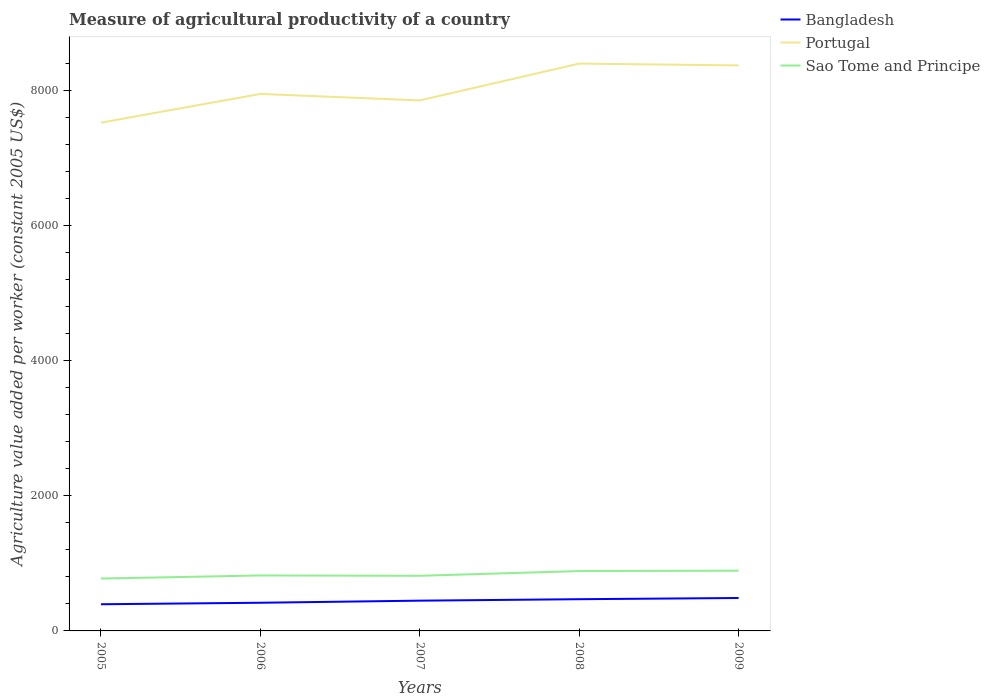Does the line corresponding to Sao Tome and Principe intersect with the line corresponding to Bangladesh?
Ensure brevity in your answer.  No. Across all years, what is the maximum measure of agricultural productivity in Portugal?
Provide a short and direct response. 7523.26. In which year was the measure of agricultural productivity in Portugal maximum?
Give a very brief answer. 2005. What is the total measure of agricultural productivity in Sao Tome and Principe in the graph?
Provide a succinct answer. -65. What is the difference between the highest and the second highest measure of agricultural productivity in Sao Tome and Principe?
Your answer should be very brief. 116.65. What is the difference between the highest and the lowest measure of agricultural productivity in Bangladesh?
Give a very brief answer. 3. How many lines are there?
Your response must be concise. 3. What is the difference between two consecutive major ticks on the Y-axis?
Offer a terse response. 2000. Are the values on the major ticks of Y-axis written in scientific E-notation?
Give a very brief answer. No. Does the graph contain any zero values?
Offer a terse response. No. Where does the legend appear in the graph?
Your response must be concise. Top right. How many legend labels are there?
Your response must be concise. 3. How are the legend labels stacked?
Offer a terse response. Vertical. What is the title of the graph?
Your response must be concise. Measure of agricultural productivity of a country. Does "Lower middle income" appear as one of the legend labels in the graph?
Offer a very short reply. No. What is the label or title of the Y-axis?
Provide a short and direct response. Agriculture value added per worker (constant 2005 US$). What is the Agriculture value added per worker (constant 2005 US$) in Bangladesh in 2005?
Offer a terse response. 394.83. What is the Agriculture value added per worker (constant 2005 US$) of Portugal in 2005?
Keep it short and to the point. 7523.26. What is the Agriculture value added per worker (constant 2005 US$) in Sao Tome and Principe in 2005?
Offer a very short reply. 775.12. What is the Agriculture value added per worker (constant 2005 US$) in Bangladesh in 2006?
Your answer should be compact. 416.92. What is the Agriculture value added per worker (constant 2005 US$) of Portugal in 2006?
Ensure brevity in your answer.  7947.86. What is the Agriculture value added per worker (constant 2005 US$) of Sao Tome and Principe in 2006?
Your answer should be compact. 820.96. What is the Agriculture value added per worker (constant 2005 US$) in Bangladesh in 2007?
Keep it short and to the point. 447.87. What is the Agriculture value added per worker (constant 2005 US$) of Portugal in 2007?
Provide a short and direct response. 7851.93. What is the Agriculture value added per worker (constant 2005 US$) in Sao Tome and Principe in 2007?
Give a very brief answer. 815.85. What is the Agriculture value added per worker (constant 2005 US$) in Bangladesh in 2008?
Offer a very short reply. 469.38. What is the Agriculture value added per worker (constant 2005 US$) of Portugal in 2008?
Ensure brevity in your answer.  8396.68. What is the Agriculture value added per worker (constant 2005 US$) in Sao Tome and Principe in 2008?
Offer a very short reply. 885.96. What is the Agriculture value added per worker (constant 2005 US$) in Bangladesh in 2009?
Offer a terse response. 487.34. What is the Agriculture value added per worker (constant 2005 US$) in Portugal in 2009?
Provide a succinct answer. 8370.22. What is the Agriculture value added per worker (constant 2005 US$) in Sao Tome and Principe in 2009?
Give a very brief answer. 891.77. Across all years, what is the maximum Agriculture value added per worker (constant 2005 US$) of Bangladesh?
Provide a short and direct response. 487.34. Across all years, what is the maximum Agriculture value added per worker (constant 2005 US$) of Portugal?
Offer a terse response. 8396.68. Across all years, what is the maximum Agriculture value added per worker (constant 2005 US$) of Sao Tome and Principe?
Provide a succinct answer. 891.77. Across all years, what is the minimum Agriculture value added per worker (constant 2005 US$) of Bangladesh?
Give a very brief answer. 394.83. Across all years, what is the minimum Agriculture value added per worker (constant 2005 US$) of Portugal?
Keep it short and to the point. 7523.26. Across all years, what is the minimum Agriculture value added per worker (constant 2005 US$) of Sao Tome and Principe?
Provide a succinct answer. 775.12. What is the total Agriculture value added per worker (constant 2005 US$) in Bangladesh in the graph?
Your answer should be very brief. 2216.33. What is the total Agriculture value added per worker (constant 2005 US$) in Portugal in the graph?
Ensure brevity in your answer.  4.01e+04. What is the total Agriculture value added per worker (constant 2005 US$) in Sao Tome and Principe in the graph?
Offer a terse response. 4189.66. What is the difference between the Agriculture value added per worker (constant 2005 US$) in Bangladesh in 2005 and that in 2006?
Give a very brief answer. -22.09. What is the difference between the Agriculture value added per worker (constant 2005 US$) of Portugal in 2005 and that in 2006?
Your response must be concise. -424.6. What is the difference between the Agriculture value added per worker (constant 2005 US$) in Sao Tome and Principe in 2005 and that in 2006?
Offer a very short reply. -45.84. What is the difference between the Agriculture value added per worker (constant 2005 US$) in Bangladesh in 2005 and that in 2007?
Your answer should be compact. -53.04. What is the difference between the Agriculture value added per worker (constant 2005 US$) in Portugal in 2005 and that in 2007?
Ensure brevity in your answer.  -328.67. What is the difference between the Agriculture value added per worker (constant 2005 US$) in Sao Tome and Principe in 2005 and that in 2007?
Provide a short and direct response. -40.73. What is the difference between the Agriculture value added per worker (constant 2005 US$) in Bangladesh in 2005 and that in 2008?
Provide a succinct answer. -74.55. What is the difference between the Agriculture value added per worker (constant 2005 US$) in Portugal in 2005 and that in 2008?
Ensure brevity in your answer.  -873.42. What is the difference between the Agriculture value added per worker (constant 2005 US$) of Sao Tome and Principe in 2005 and that in 2008?
Provide a short and direct response. -110.84. What is the difference between the Agriculture value added per worker (constant 2005 US$) of Bangladesh in 2005 and that in 2009?
Your answer should be compact. -92.51. What is the difference between the Agriculture value added per worker (constant 2005 US$) in Portugal in 2005 and that in 2009?
Ensure brevity in your answer.  -846.96. What is the difference between the Agriculture value added per worker (constant 2005 US$) in Sao Tome and Principe in 2005 and that in 2009?
Provide a succinct answer. -116.65. What is the difference between the Agriculture value added per worker (constant 2005 US$) of Bangladesh in 2006 and that in 2007?
Provide a short and direct response. -30.95. What is the difference between the Agriculture value added per worker (constant 2005 US$) in Portugal in 2006 and that in 2007?
Make the answer very short. 95.93. What is the difference between the Agriculture value added per worker (constant 2005 US$) in Sao Tome and Principe in 2006 and that in 2007?
Your answer should be compact. 5.11. What is the difference between the Agriculture value added per worker (constant 2005 US$) of Bangladesh in 2006 and that in 2008?
Give a very brief answer. -52.46. What is the difference between the Agriculture value added per worker (constant 2005 US$) in Portugal in 2006 and that in 2008?
Provide a short and direct response. -448.83. What is the difference between the Agriculture value added per worker (constant 2005 US$) of Sao Tome and Principe in 2006 and that in 2008?
Keep it short and to the point. -65. What is the difference between the Agriculture value added per worker (constant 2005 US$) in Bangladesh in 2006 and that in 2009?
Your answer should be compact. -70.42. What is the difference between the Agriculture value added per worker (constant 2005 US$) of Portugal in 2006 and that in 2009?
Offer a terse response. -422.36. What is the difference between the Agriculture value added per worker (constant 2005 US$) of Sao Tome and Principe in 2006 and that in 2009?
Your response must be concise. -70.81. What is the difference between the Agriculture value added per worker (constant 2005 US$) in Bangladesh in 2007 and that in 2008?
Offer a very short reply. -21.52. What is the difference between the Agriculture value added per worker (constant 2005 US$) in Portugal in 2007 and that in 2008?
Offer a terse response. -544.76. What is the difference between the Agriculture value added per worker (constant 2005 US$) of Sao Tome and Principe in 2007 and that in 2008?
Make the answer very short. -70.11. What is the difference between the Agriculture value added per worker (constant 2005 US$) in Bangladesh in 2007 and that in 2009?
Your response must be concise. -39.47. What is the difference between the Agriculture value added per worker (constant 2005 US$) of Portugal in 2007 and that in 2009?
Your answer should be very brief. -518.29. What is the difference between the Agriculture value added per worker (constant 2005 US$) of Sao Tome and Principe in 2007 and that in 2009?
Keep it short and to the point. -75.92. What is the difference between the Agriculture value added per worker (constant 2005 US$) in Bangladesh in 2008 and that in 2009?
Offer a terse response. -17.96. What is the difference between the Agriculture value added per worker (constant 2005 US$) of Portugal in 2008 and that in 2009?
Provide a succinct answer. 26.46. What is the difference between the Agriculture value added per worker (constant 2005 US$) of Sao Tome and Principe in 2008 and that in 2009?
Give a very brief answer. -5.81. What is the difference between the Agriculture value added per worker (constant 2005 US$) in Bangladesh in 2005 and the Agriculture value added per worker (constant 2005 US$) in Portugal in 2006?
Offer a very short reply. -7553.03. What is the difference between the Agriculture value added per worker (constant 2005 US$) of Bangladesh in 2005 and the Agriculture value added per worker (constant 2005 US$) of Sao Tome and Principe in 2006?
Keep it short and to the point. -426.13. What is the difference between the Agriculture value added per worker (constant 2005 US$) of Portugal in 2005 and the Agriculture value added per worker (constant 2005 US$) of Sao Tome and Principe in 2006?
Provide a short and direct response. 6702.3. What is the difference between the Agriculture value added per worker (constant 2005 US$) in Bangladesh in 2005 and the Agriculture value added per worker (constant 2005 US$) in Portugal in 2007?
Provide a short and direct response. -7457.1. What is the difference between the Agriculture value added per worker (constant 2005 US$) of Bangladesh in 2005 and the Agriculture value added per worker (constant 2005 US$) of Sao Tome and Principe in 2007?
Ensure brevity in your answer.  -421.02. What is the difference between the Agriculture value added per worker (constant 2005 US$) of Portugal in 2005 and the Agriculture value added per worker (constant 2005 US$) of Sao Tome and Principe in 2007?
Give a very brief answer. 6707.41. What is the difference between the Agriculture value added per worker (constant 2005 US$) in Bangladesh in 2005 and the Agriculture value added per worker (constant 2005 US$) in Portugal in 2008?
Your answer should be very brief. -8001.86. What is the difference between the Agriculture value added per worker (constant 2005 US$) in Bangladesh in 2005 and the Agriculture value added per worker (constant 2005 US$) in Sao Tome and Principe in 2008?
Give a very brief answer. -491.13. What is the difference between the Agriculture value added per worker (constant 2005 US$) of Portugal in 2005 and the Agriculture value added per worker (constant 2005 US$) of Sao Tome and Principe in 2008?
Provide a succinct answer. 6637.3. What is the difference between the Agriculture value added per worker (constant 2005 US$) in Bangladesh in 2005 and the Agriculture value added per worker (constant 2005 US$) in Portugal in 2009?
Your answer should be compact. -7975.39. What is the difference between the Agriculture value added per worker (constant 2005 US$) in Bangladesh in 2005 and the Agriculture value added per worker (constant 2005 US$) in Sao Tome and Principe in 2009?
Offer a very short reply. -496.94. What is the difference between the Agriculture value added per worker (constant 2005 US$) in Portugal in 2005 and the Agriculture value added per worker (constant 2005 US$) in Sao Tome and Principe in 2009?
Your response must be concise. 6631.49. What is the difference between the Agriculture value added per worker (constant 2005 US$) in Bangladesh in 2006 and the Agriculture value added per worker (constant 2005 US$) in Portugal in 2007?
Your answer should be compact. -7435.01. What is the difference between the Agriculture value added per worker (constant 2005 US$) in Bangladesh in 2006 and the Agriculture value added per worker (constant 2005 US$) in Sao Tome and Principe in 2007?
Your answer should be compact. -398.93. What is the difference between the Agriculture value added per worker (constant 2005 US$) in Portugal in 2006 and the Agriculture value added per worker (constant 2005 US$) in Sao Tome and Principe in 2007?
Ensure brevity in your answer.  7132.01. What is the difference between the Agriculture value added per worker (constant 2005 US$) of Bangladesh in 2006 and the Agriculture value added per worker (constant 2005 US$) of Portugal in 2008?
Offer a very short reply. -7979.77. What is the difference between the Agriculture value added per worker (constant 2005 US$) in Bangladesh in 2006 and the Agriculture value added per worker (constant 2005 US$) in Sao Tome and Principe in 2008?
Provide a succinct answer. -469.04. What is the difference between the Agriculture value added per worker (constant 2005 US$) of Portugal in 2006 and the Agriculture value added per worker (constant 2005 US$) of Sao Tome and Principe in 2008?
Ensure brevity in your answer.  7061.9. What is the difference between the Agriculture value added per worker (constant 2005 US$) in Bangladesh in 2006 and the Agriculture value added per worker (constant 2005 US$) in Portugal in 2009?
Your answer should be compact. -7953.3. What is the difference between the Agriculture value added per worker (constant 2005 US$) in Bangladesh in 2006 and the Agriculture value added per worker (constant 2005 US$) in Sao Tome and Principe in 2009?
Give a very brief answer. -474.85. What is the difference between the Agriculture value added per worker (constant 2005 US$) in Portugal in 2006 and the Agriculture value added per worker (constant 2005 US$) in Sao Tome and Principe in 2009?
Your answer should be compact. 7056.09. What is the difference between the Agriculture value added per worker (constant 2005 US$) of Bangladesh in 2007 and the Agriculture value added per worker (constant 2005 US$) of Portugal in 2008?
Make the answer very short. -7948.82. What is the difference between the Agriculture value added per worker (constant 2005 US$) in Bangladesh in 2007 and the Agriculture value added per worker (constant 2005 US$) in Sao Tome and Principe in 2008?
Your answer should be compact. -438.1. What is the difference between the Agriculture value added per worker (constant 2005 US$) of Portugal in 2007 and the Agriculture value added per worker (constant 2005 US$) of Sao Tome and Principe in 2008?
Make the answer very short. 6965.97. What is the difference between the Agriculture value added per worker (constant 2005 US$) of Bangladesh in 2007 and the Agriculture value added per worker (constant 2005 US$) of Portugal in 2009?
Offer a very short reply. -7922.36. What is the difference between the Agriculture value added per worker (constant 2005 US$) of Bangladesh in 2007 and the Agriculture value added per worker (constant 2005 US$) of Sao Tome and Principe in 2009?
Keep it short and to the point. -443.9. What is the difference between the Agriculture value added per worker (constant 2005 US$) of Portugal in 2007 and the Agriculture value added per worker (constant 2005 US$) of Sao Tome and Principe in 2009?
Offer a terse response. 6960.16. What is the difference between the Agriculture value added per worker (constant 2005 US$) in Bangladesh in 2008 and the Agriculture value added per worker (constant 2005 US$) in Portugal in 2009?
Offer a very short reply. -7900.84. What is the difference between the Agriculture value added per worker (constant 2005 US$) of Bangladesh in 2008 and the Agriculture value added per worker (constant 2005 US$) of Sao Tome and Principe in 2009?
Make the answer very short. -422.39. What is the difference between the Agriculture value added per worker (constant 2005 US$) of Portugal in 2008 and the Agriculture value added per worker (constant 2005 US$) of Sao Tome and Principe in 2009?
Make the answer very short. 7504.91. What is the average Agriculture value added per worker (constant 2005 US$) of Bangladesh per year?
Your answer should be very brief. 443.27. What is the average Agriculture value added per worker (constant 2005 US$) of Portugal per year?
Keep it short and to the point. 8017.99. What is the average Agriculture value added per worker (constant 2005 US$) in Sao Tome and Principe per year?
Provide a succinct answer. 837.93. In the year 2005, what is the difference between the Agriculture value added per worker (constant 2005 US$) in Bangladesh and Agriculture value added per worker (constant 2005 US$) in Portugal?
Provide a short and direct response. -7128.43. In the year 2005, what is the difference between the Agriculture value added per worker (constant 2005 US$) of Bangladesh and Agriculture value added per worker (constant 2005 US$) of Sao Tome and Principe?
Give a very brief answer. -380.29. In the year 2005, what is the difference between the Agriculture value added per worker (constant 2005 US$) in Portugal and Agriculture value added per worker (constant 2005 US$) in Sao Tome and Principe?
Your response must be concise. 6748.14. In the year 2006, what is the difference between the Agriculture value added per worker (constant 2005 US$) in Bangladesh and Agriculture value added per worker (constant 2005 US$) in Portugal?
Keep it short and to the point. -7530.94. In the year 2006, what is the difference between the Agriculture value added per worker (constant 2005 US$) in Bangladesh and Agriculture value added per worker (constant 2005 US$) in Sao Tome and Principe?
Provide a succinct answer. -404.04. In the year 2006, what is the difference between the Agriculture value added per worker (constant 2005 US$) in Portugal and Agriculture value added per worker (constant 2005 US$) in Sao Tome and Principe?
Provide a succinct answer. 7126.9. In the year 2007, what is the difference between the Agriculture value added per worker (constant 2005 US$) in Bangladesh and Agriculture value added per worker (constant 2005 US$) in Portugal?
Your answer should be compact. -7404.06. In the year 2007, what is the difference between the Agriculture value added per worker (constant 2005 US$) in Bangladesh and Agriculture value added per worker (constant 2005 US$) in Sao Tome and Principe?
Your answer should be compact. -367.98. In the year 2007, what is the difference between the Agriculture value added per worker (constant 2005 US$) of Portugal and Agriculture value added per worker (constant 2005 US$) of Sao Tome and Principe?
Make the answer very short. 7036.08. In the year 2008, what is the difference between the Agriculture value added per worker (constant 2005 US$) of Bangladesh and Agriculture value added per worker (constant 2005 US$) of Portugal?
Offer a terse response. -7927.3. In the year 2008, what is the difference between the Agriculture value added per worker (constant 2005 US$) of Bangladesh and Agriculture value added per worker (constant 2005 US$) of Sao Tome and Principe?
Keep it short and to the point. -416.58. In the year 2008, what is the difference between the Agriculture value added per worker (constant 2005 US$) of Portugal and Agriculture value added per worker (constant 2005 US$) of Sao Tome and Principe?
Ensure brevity in your answer.  7510.72. In the year 2009, what is the difference between the Agriculture value added per worker (constant 2005 US$) of Bangladesh and Agriculture value added per worker (constant 2005 US$) of Portugal?
Give a very brief answer. -7882.88. In the year 2009, what is the difference between the Agriculture value added per worker (constant 2005 US$) in Bangladesh and Agriculture value added per worker (constant 2005 US$) in Sao Tome and Principe?
Offer a very short reply. -404.43. In the year 2009, what is the difference between the Agriculture value added per worker (constant 2005 US$) of Portugal and Agriculture value added per worker (constant 2005 US$) of Sao Tome and Principe?
Offer a terse response. 7478.45. What is the ratio of the Agriculture value added per worker (constant 2005 US$) of Bangladesh in 2005 to that in 2006?
Offer a terse response. 0.95. What is the ratio of the Agriculture value added per worker (constant 2005 US$) of Portugal in 2005 to that in 2006?
Your answer should be compact. 0.95. What is the ratio of the Agriculture value added per worker (constant 2005 US$) of Sao Tome and Principe in 2005 to that in 2006?
Your answer should be very brief. 0.94. What is the ratio of the Agriculture value added per worker (constant 2005 US$) of Bangladesh in 2005 to that in 2007?
Your response must be concise. 0.88. What is the ratio of the Agriculture value added per worker (constant 2005 US$) in Portugal in 2005 to that in 2007?
Your answer should be very brief. 0.96. What is the ratio of the Agriculture value added per worker (constant 2005 US$) of Sao Tome and Principe in 2005 to that in 2007?
Offer a terse response. 0.95. What is the ratio of the Agriculture value added per worker (constant 2005 US$) of Bangladesh in 2005 to that in 2008?
Your answer should be very brief. 0.84. What is the ratio of the Agriculture value added per worker (constant 2005 US$) of Portugal in 2005 to that in 2008?
Make the answer very short. 0.9. What is the ratio of the Agriculture value added per worker (constant 2005 US$) of Sao Tome and Principe in 2005 to that in 2008?
Keep it short and to the point. 0.87. What is the ratio of the Agriculture value added per worker (constant 2005 US$) in Bangladesh in 2005 to that in 2009?
Provide a succinct answer. 0.81. What is the ratio of the Agriculture value added per worker (constant 2005 US$) in Portugal in 2005 to that in 2009?
Keep it short and to the point. 0.9. What is the ratio of the Agriculture value added per worker (constant 2005 US$) in Sao Tome and Principe in 2005 to that in 2009?
Your answer should be very brief. 0.87. What is the ratio of the Agriculture value added per worker (constant 2005 US$) in Bangladesh in 2006 to that in 2007?
Ensure brevity in your answer.  0.93. What is the ratio of the Agriculture value added per worker (constant 2005 US$) in Portugal in 2006 to that in 2007?
Provide a short and direct response. 1.01. What is the ratio of the Agriculture value added per worker (constant 2005 US$) of Sao Tome and Principe in 2006 to that in 2007?
Ensure brevity in your answer.  1.01. What is the ratio of the Agriculture value added per worker (constant 2005 US$) of Bangladesh in 2006 to that in 2008?
Your answer should be very brief. 0.89. What is the ratio of the Agriculture value added per worker (constant 2005 US$) of Portugal in 2006 to that in 2008?
Your response must be concise. 0.95. What is the ratio of the Agriculture value added per worker (constant 2005 US$) in Sao Tome and Principe in 2006 to that in 2008?
Your answer should be compact. 0.93. What is the ratio of the Agriculture value added per worker (constant 2005 US$) in Bangladesh in 2006 to that in 2009?
Provide a short and direct response. 0.86. What is the ratio of the Agriculture value added per worker (constant 2005 US$) of Portugal in 2006 to that in 2009?
Give a very brief answer. 0.95. What is the ratio of the Agriculture value added per worker (constant 2005 US$) in Sao Tome and Principe in 2006 to that in 2009?
Your answer should be very brief. 0.92. What is the ratio of the Agriculture value added per worker (constant 2005 US$) in Bangladesh in 2007 to that in 2008?
Provide a short and direct response. 0.95. What is the ratio of the Agriculture value added per worker (constant 2005 US$) in Portugal in 2007 to that in 2008?
Your answer should be very brief. 0.94. What is the ratio of the Agriculture value added per worker (constant 2005 US$) in Sao Tome and Principe in 2007 to that in 2008?
Give a very brief answer. 0.92. What is the ratio of the Agriculture value added per worker (constant 2005 US$) of Bangladesh in 2007 to that in 2009?
Keep it short and to the point. 0.92. What is the ratio of the Agriculture value added per worker (constant 2005 US$) of Portugal in 2007 to that in 2009?
Make the answer very short. 0.94. What is the ratio of the Agriculture value added per worker (constant 2005 US$) of Sao Tome and Principe in 2007 to that in 2009?
Offer a very short reply. 0.91. What is the ratio of the Agriculture value added per worker (constant 2005 US$) of Bangladesh in 2008 to that in 2009?
Your answer should be compact. 0.96. What is the ratio of the Agriculture value added per worker (constant 2005 US$) in Portugal in 2008 to that in 2009?
Provide a short and direct response. 1. What is the ratio of the Agriculture value added per worker (constant 2005 US$) in Sao Tome and Principe in 2008 to that in 2009?
Ensure brevity in your answer.  0.99. What is the difference between the highest and the second highest Agriculture value added per worker (constant 2005 US$) in Bangladesh?
Offer a terse response. 17.96. What is the difference between the highest and the second highest Agriculture value added per worker (constant 2005 US$) of Portugal?
Offer a terse response. 26.46. What is the difference between the highest and the second highest Agriculture value added per worker (constant 2005 US$) in Sao Tome and Principe?
Offer a terse response. 5.81. What is the difference between the highest and the lowest Agriculture value added per worker (constant 2005 US$) of Bangladesh?
Provide a succinct answer. 92.51. What is the difference between the highest and the lowest Agriculture value added per worker (constant 2005 US$) in Portugal?
Make the answer very short. 873.42. What is the difference between the highest and the lowest Agriculture value added per worker (constant 2005 US$) in Sao Tome and Principe?
Your answer should be very brief. 116.65. 